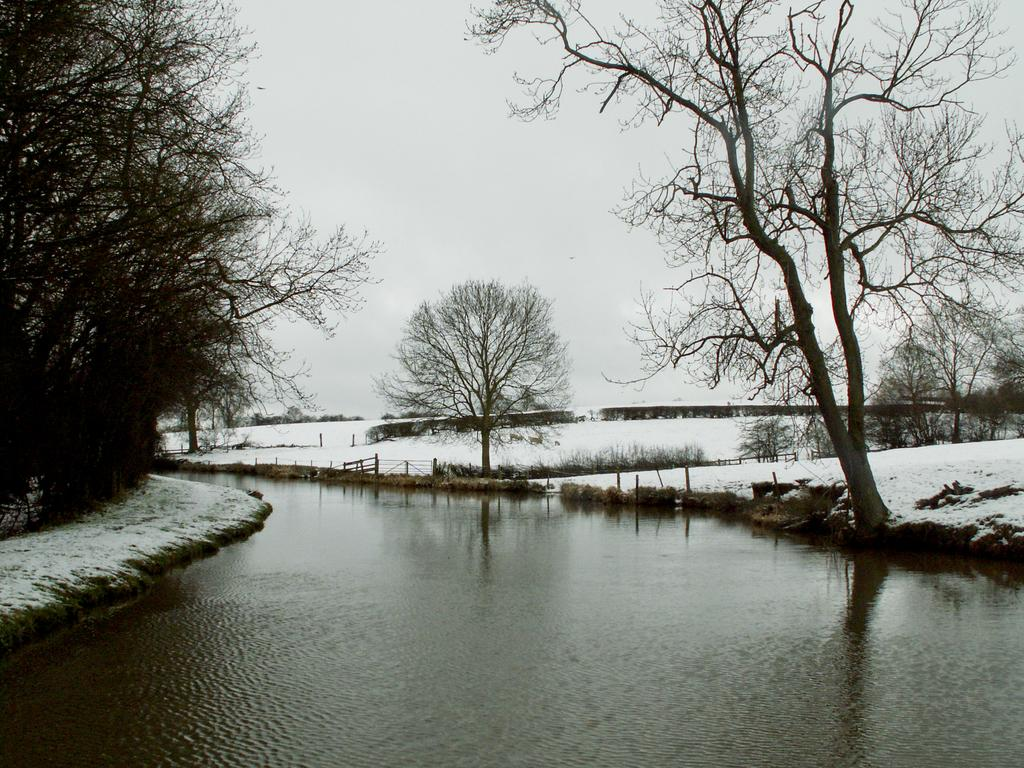What type of environment is depicted in the image? The image is an outside view. What body of water is present at the bottom of the image? There is a river at the bottom of the image. What type of vegetation can be seen in the background of the image? There are trees in the background of the image. What is the condition of the ground in the image? The ground has snow. What is visible at the top of the image? The sky is visible at the top of the image. Can you hear the rabbit hopping in the image? There is no rabbit present in the image, and therefore no sound of hopping can be heard. How does the light affect the visibility of the river in the image? The image does not provide information about the light, so we cannot determine how it affects the visibility of the river. 